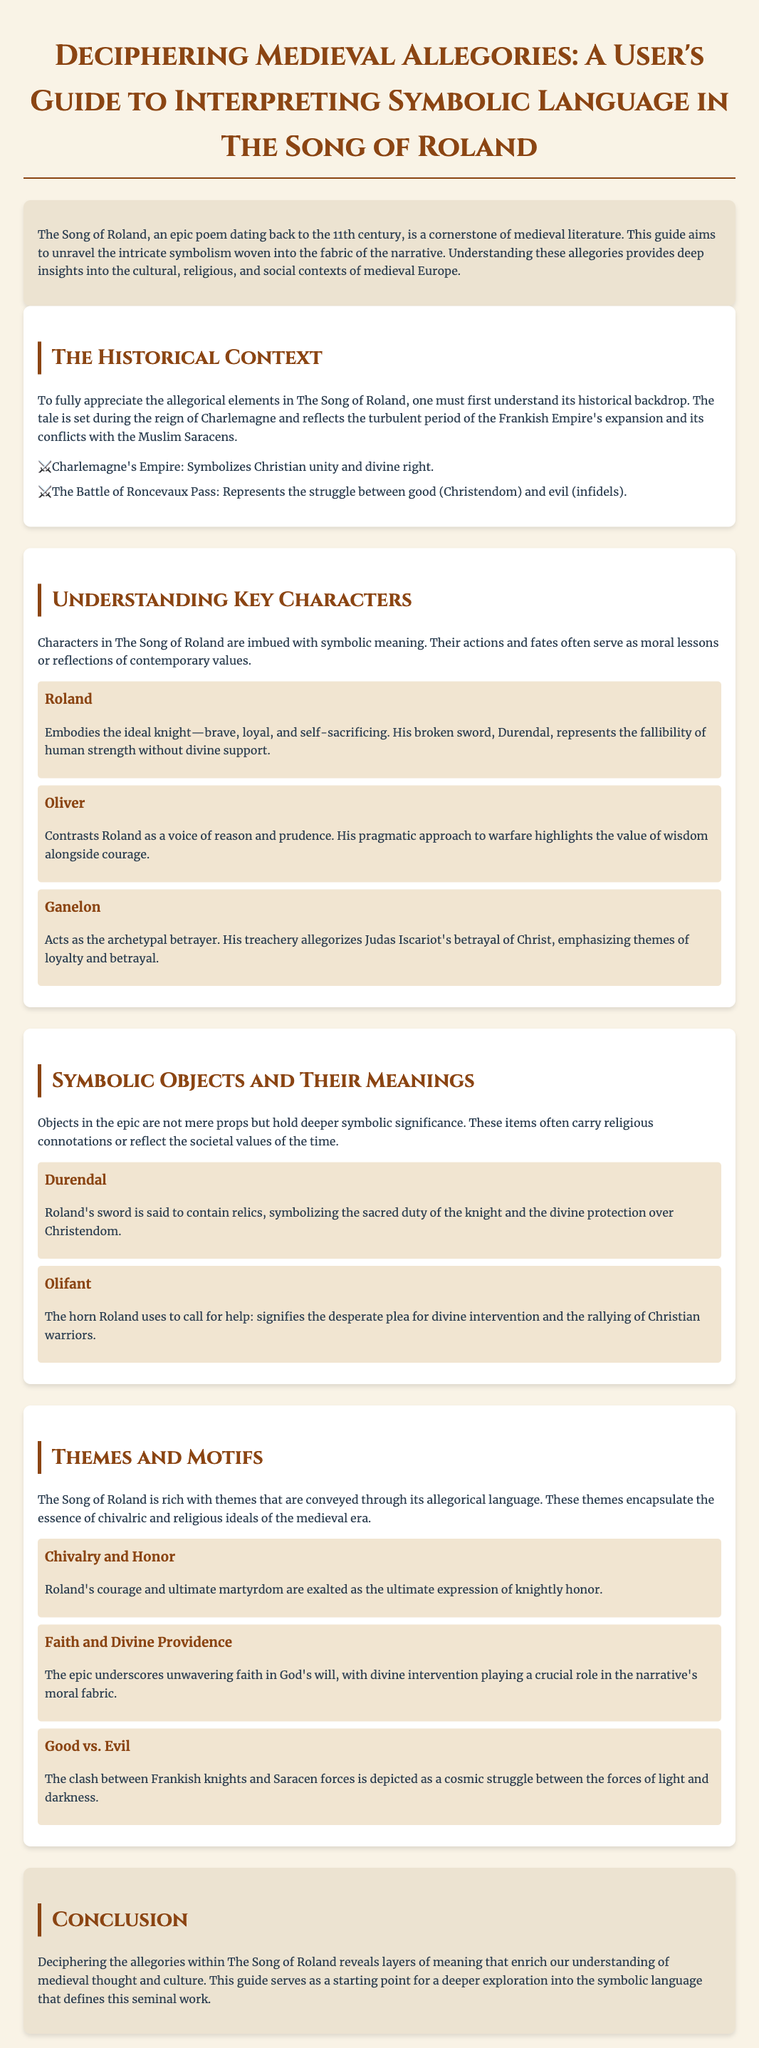What is the title of the guide? The title is displayed prominently at the top of the document and is "Deciphering Medieval Allegories: A User's Guide to Interpreting Symbolic Language in The Song of Roland."
Answer: Deciphering Medieval Allegories: A User's Guide to Interpreting Symbolic Language in The Song of Roland Who is the main character representing the ideal knight? The character most associated with the ideal knight's qualities is specified in the section about understanding key characters.
Answer: Roland What does the horn Olifant symbolize? The symbolism of the horn is explained in the section on symbolic objects, highlighting its deeper meaning.
Answer: The desperate plea for divine intervention What theme is emphasized through Roland’s courage and martyrdom? This theme is discussed in the themes and motifs section, linking it to the chivalric ideals of the time.
Answer: Chivalry and Honor What historical period does The Song of Roland reflect? The document provides historical context to the poem, identifying the timeframe in which the narrative is set.
Answer: The reign of Charlemagne Which character acts as the archetypal betrayer? The section on understanding key characters specifies which character embodies betrayal's archetype.
Answer: Ganelon What divine theme plays a crucial role in the narrative? The profound theme referenced in the themes section emphasizes the importance of faith.
Answer: Faith and Divine Providence How many sections are there in the document? By counting the distinct sections outlined after the introduction, the number can be easily identified.
Answer: Four 